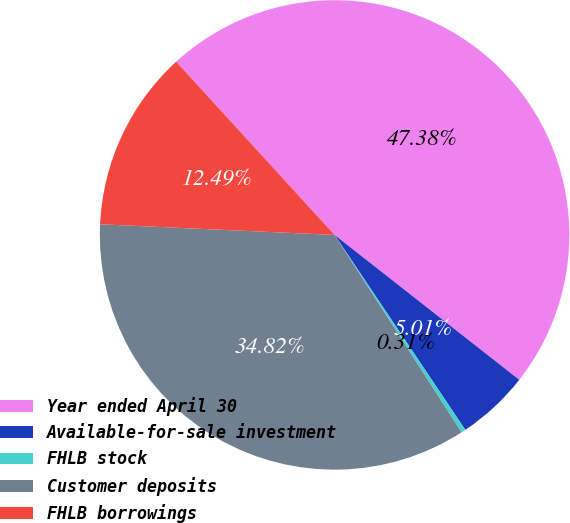Convert chart. <chart><loc_0><loc_0><loc_500><loc_500><pie_chart><fcel>Year ended April 30<fcel>Available-for-sale investment<fcel>FHLB stock<fcel>Customer deposits<fcel>FHLB borrowings<nl><fcel>47.38%<fcel>5.01%<fcel>0.31%<fcel>34.82%<fcel>12.49%<nl></chart> 